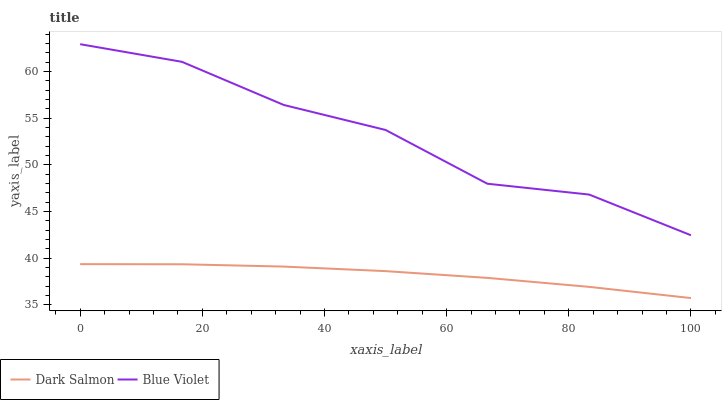Does Dark Salmon have the minimum area under the curve?
Answer yes or no. Yes. Does Blue Violet have the maximum area under the curve?
Answer yes or no. Yes. Does Blue Violet have the minimum area under the curve?
Answer yes or no. No. Is Dark Salmon the smoothest?
Answer yes or no. Yes. Is Blue Violet the roughest?
Answer yes or no. Yes. Is Blue Violet the smoothest?
Answer yes or no. No. Does Dark Salmon have the lowest value?
Answer yes or no. Yes. Does Blue Violet have the lowest value?
Answer yes or no. No. Does Blue Violet have the highest value?
Answer yes or no. Yes. Is Dark Salmon less than Blue Violet?
Answer yes or no. Yes. Is Blue Violet greater than Dark Salmon?
Answer yes or no. Yes. Does Dark Salmon intersect Blue Violet?
Answer yes or no. No. 